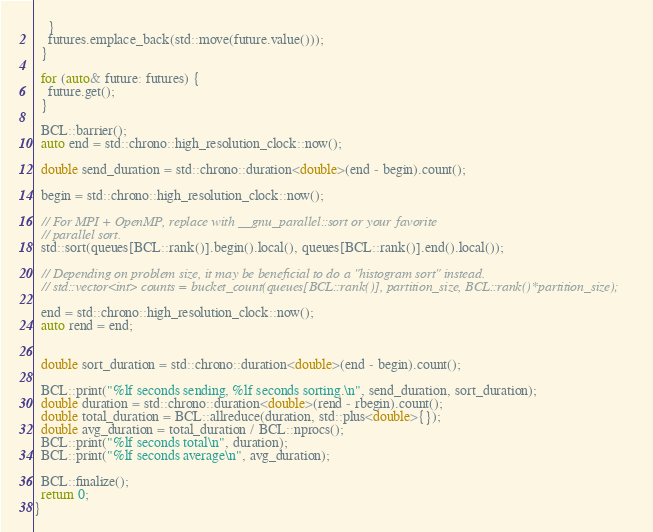<code> <loc_0><loc_0><loc_500><loc_500><_C++_>    }
    futures.emplace_back(std::move(future.value()));
  }

  for (auto& future: futures) {
    future.get();
  }

  BCL::barrier();
  auto end = std::chrono::high_resolution_clock::now();

  double send_duration = std::chrono::duration<double>(end - begin).count();

  begin = std::chrono::high_resolution_clock::now();

  // For MPI + OpenMP, replace with __gnu_parallel::sort or your favorite
  // parallel sort.
  std::sort(queues[BCL::rank()].begin().local(), queues[BCL::rank()].end().local());

  // Depending on problem size, it may be beneficial to do a "histogram sort" instead.
  // std::vector<int> counts = bucket_count(queues[BCL::rank()], partition_size, BCL::rank()*partition_size);

  end = std::chrono::high_resolution_clock::now();
  auto rend = end;


  double sort_duration = std::chrono::duration<double>(end - begin).count();

  BCL::print("%lf seconds sending, %lf seconds sorting.\n", send_duration, sort_duration);
  double duration = std::chrono::duration<double>(rend - rbegin).count();
  double total_duration = BCL::allreduce(duration, std::plus<double>{});
  double avg_duration = total_duration / BCL::nprocs();
  BCL::print("%lf seconds total\n", duration);
  BCL::print("%lf seconds average\n", avg_duration);

  BCL::finalize();
  return 0;
}
</code> 